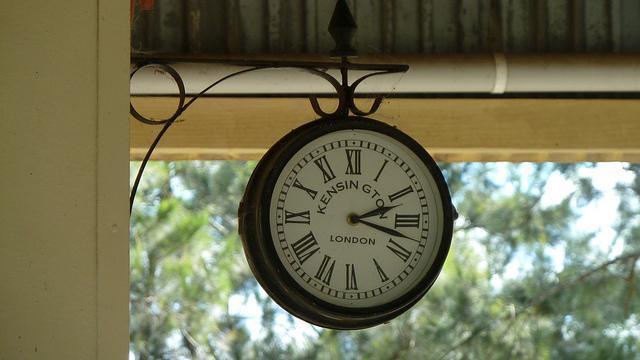How many elephants are there?
Give a very brief answer. 0. 